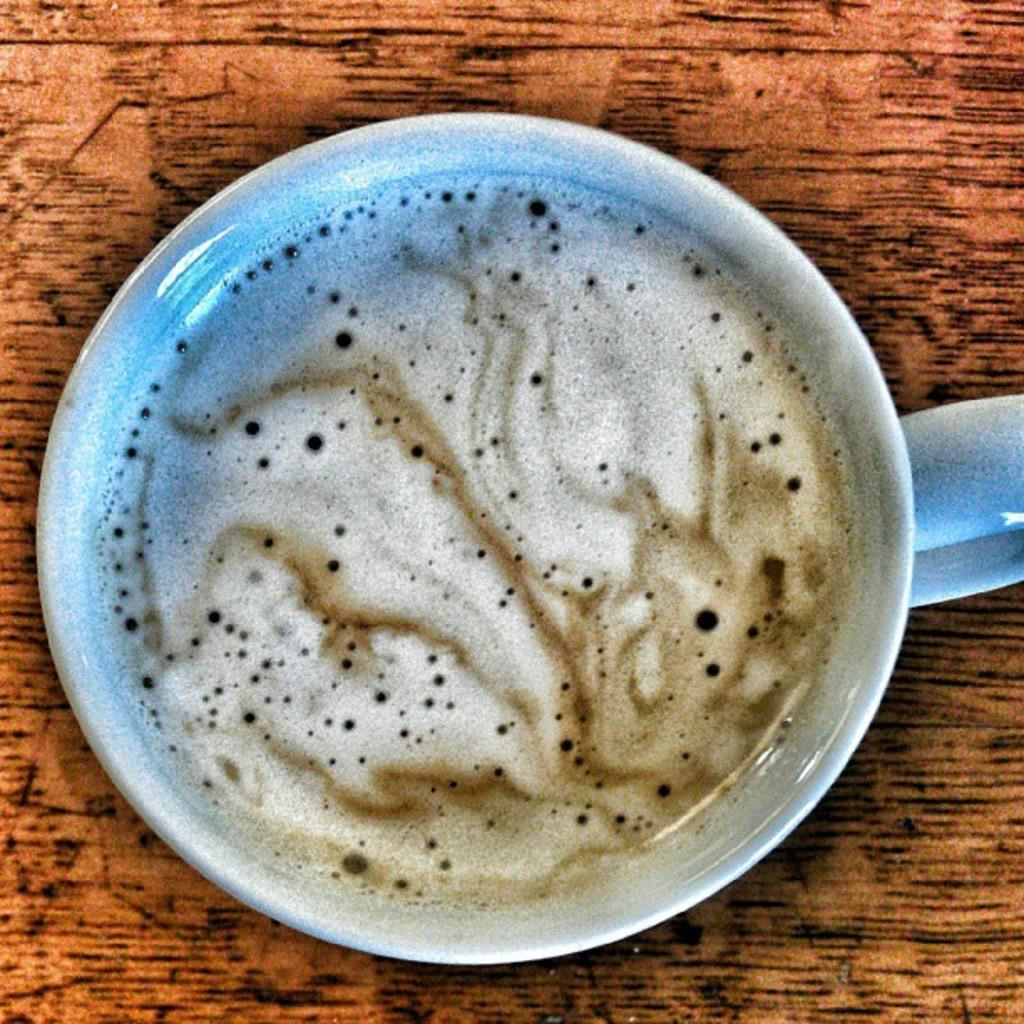What is in the cup that is visible in the image? There is coffee in the cup in the image. Where is the cup located in the image? The cup is placed on a table in the image. What type of clouds can be seen in the image? There are no clouds visible in the image, as it only features a cup of coffee on a table. How many circles are present in the image? There are no circles explicitly mentioned or depicted in the image. 